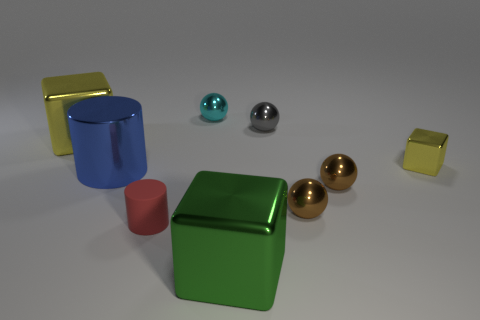How many cylinders are either big green metallic things or red rubber things?
Offer a very short reply. 1. Are there fewer brown shiny spheres that are on the left side of the metallic cylinder than big metal cylinders?
Ensure brevity in your answer.  Yes. What number of other things are made of the same material as the big yellow thing?
Your answer should be very brief. 7. Is the cyan sphere the same size as the green block?
Offer a terse response. No. What number of objects are large objects that are in front of the blue metallic cylinder or green cubes?
Offer a terse response. 1. What is the material of the tiny sphere left of the big shiny block that is in front of the large metallic cylinder?
Offer a very short reply. Metal. Is there another big metallic thing that has the same shape as the big blue object?
Your answer should be very brief. No. Does the cyan metallic object have the same size as the shiny block left of the big blue thing?
Offer a terse response. No. How many objects are large cubes in front of the big yellow metallic block or metallic objects left of the red cylinder?
Your answer should be very brief. 3. Is the number of small spheres that are behind the tiny gray metallic object greater than the number of cyan cylinders?
Make the answer very short. Yes. 